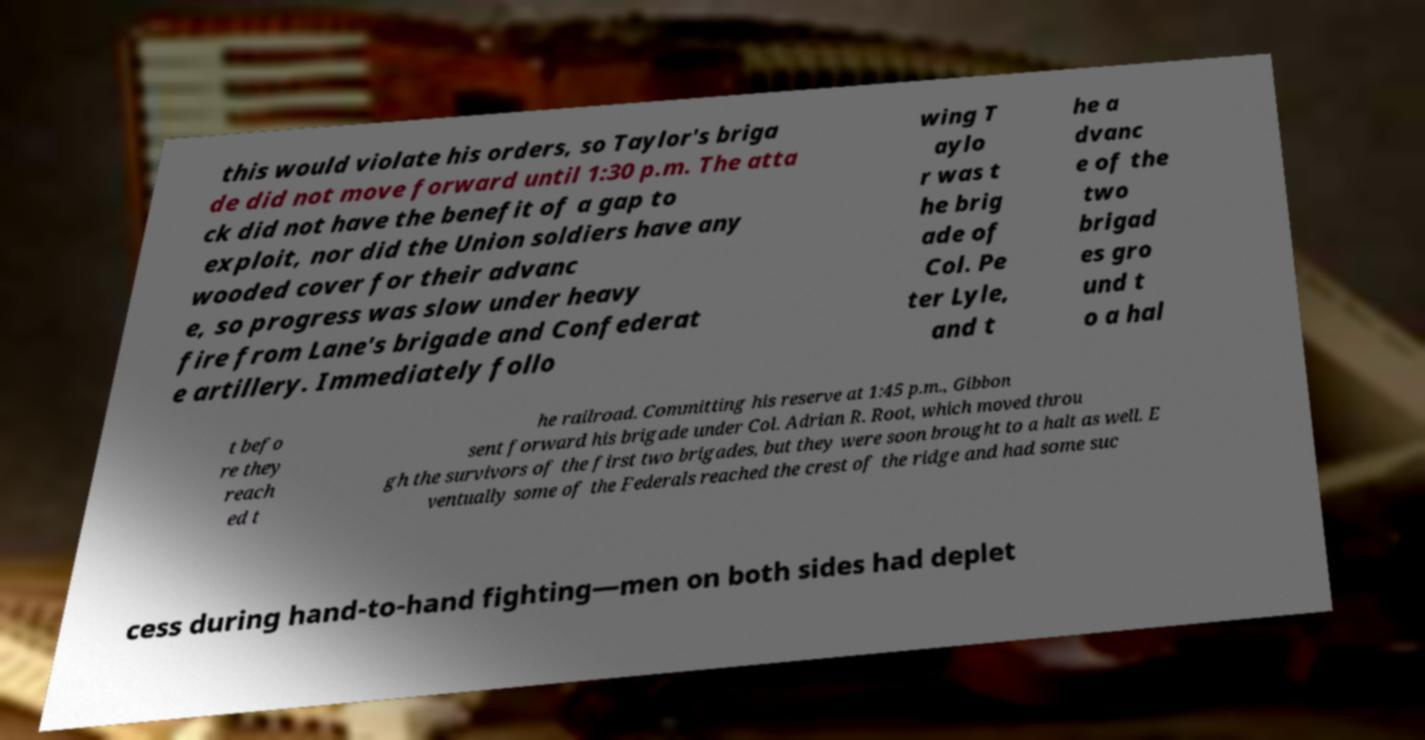Please read and relay the text visible in this image. What does it say? this would violate his orders, so Taylor's briga de did not move forward until 1:30 p.m. The atta ck did not have the benefit of a gap to exploit, nor did the Union soldiers have any wooded cover for their advanc e, so progress was slow under heavy fire from Lane's brigade and Confederat e artillery. Immediately follo wing T aylo r was t he brig ade of Col. Pe ter Lyle, and t he a dvanc e of the two brigad es gro und t o a hal t befo re they reach ed t he railroad. Committing his reserve at 1:45 p.m., Gibbon sent forward his brigade under Col. Adrian R. Root, which moved throu gh the survivors of the first two brigades, but they were soon brought to a halt as well. E ventually some of the Federals reached the crest of the ridge and had some suc cess during hand-to-hand fighting—men on both sides had deplet 